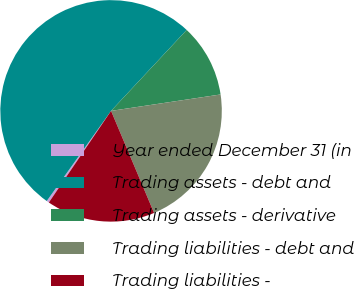<chart> <loc_0><loc_0><loc_500><loc_500><pie_chart><fcel>Year ended December 31 (in<fcel>Trading assets - debt and<fcel>Trading assets - derivative<fcel>Trading liabilities - debt and<fcel>Trading liabilities -<nl><fcel>0.37%<fcel>52.1%<fcel>10.67%<fcel>21.02%<fcel>15.84%<nl></chart> 